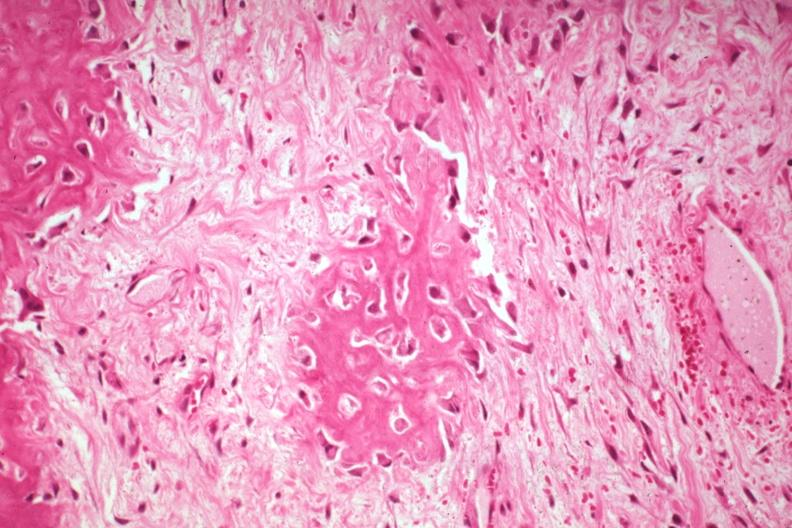how does this image show high fibrous callus and osteoid?
Answer the question using a single word or phrase. With osteoblasts from a non-union 